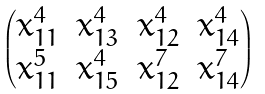<formula> <loc_0><loc_0><loc_500><loc_500>\begin{pmatrix} x _ { 1 1 } ^ { 4 } & x _ { 1 3 } ^ { 4 } & x _ { 1 2 } ^ { 4 } & x _ { 1 4 } ^ { 4 } \\ x _ { 1 1 } ^ { 5 } & x _ { 1 5 } ^ { 4 } & x _ { 1 2 } ^ { 7 } & x _ { 1 4 } ^ { 7 } \end{pmatrix}</formula> 